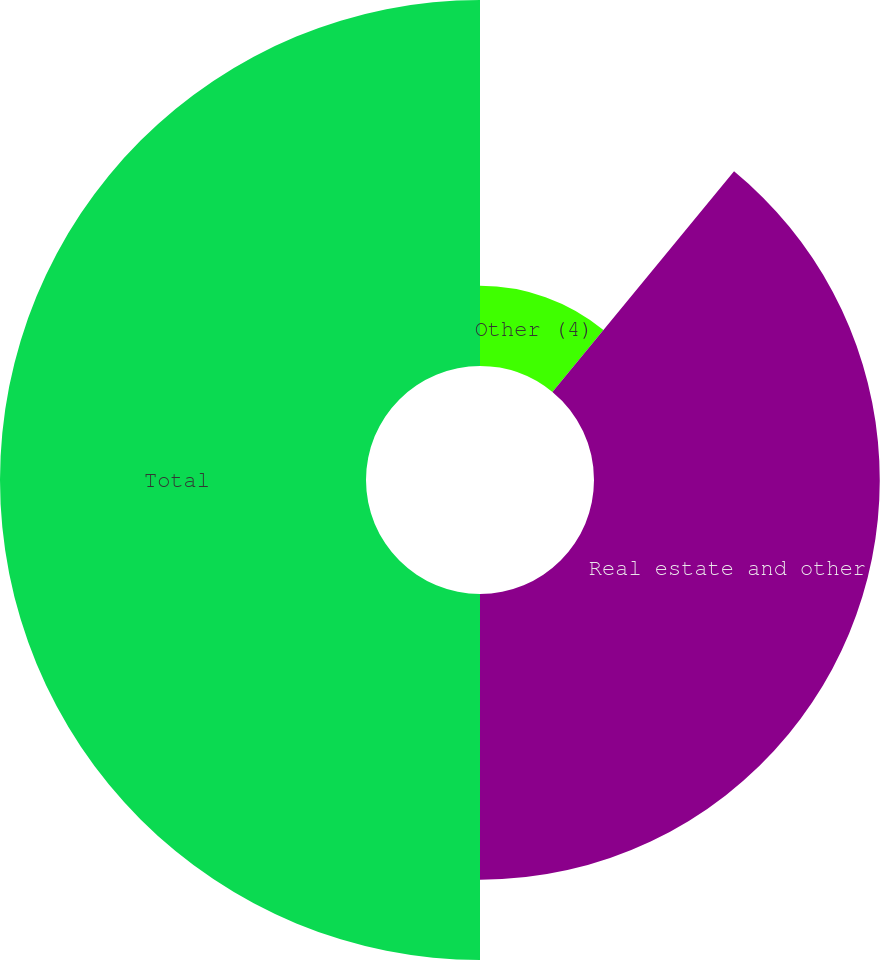<chart> <loc_0><loc_0><loc_500><loc_500><pie_chart><fcel>Other (4)<fcel>Real estate and other<fcel>Total<nl><fcel>10.96%<fcel>39.04%<fcel>50.0%<nl></chart> 